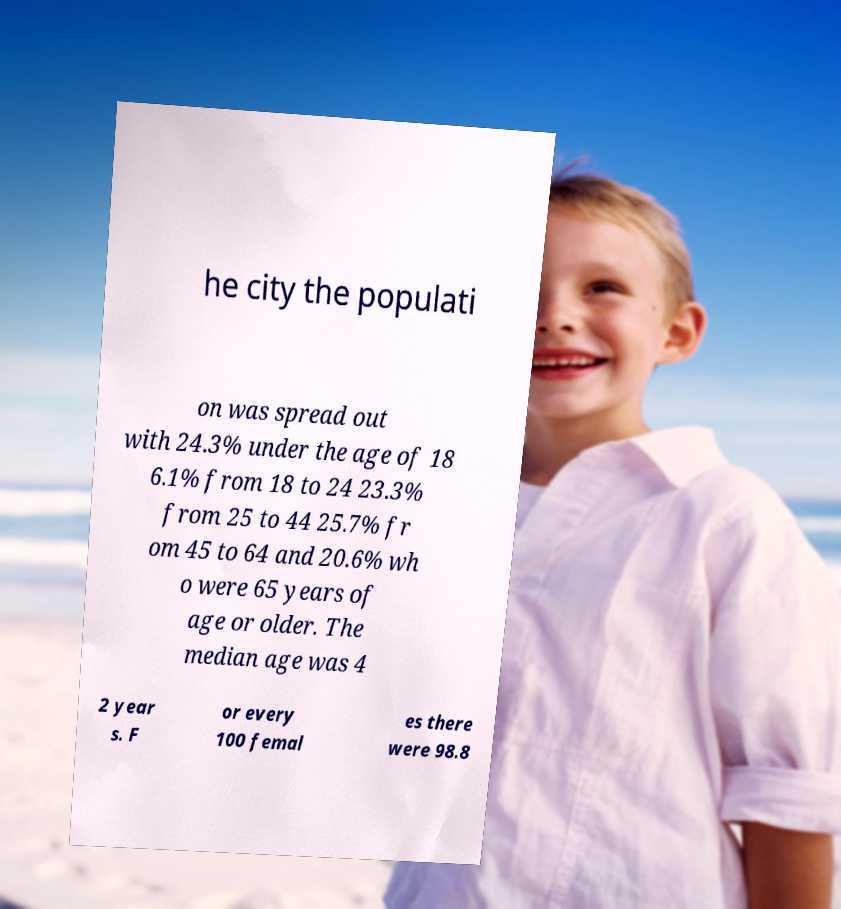Could you extract and type out the text from this image? he city the populati on was spread out with 24.3% under the age of 18 6.1% from 18 to 24 23.3% from 25 to 44 25.7% fr om 45 to 64 and 20.6% wh o were 65 years of age or older. The median age was 4 2 year s. F or every 100 femal es there were 98.8 